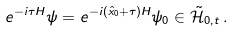<formula> <loc_0><loc_0><loc_500><loc_500>e ^ { - i \tau H } \psi = e ^ { - i \left ( \hat { x } _ { 0 } + \tau \right ) H } \psi _ { 0 } \in \tilde { \mathcal { H } } _ { 0 , t } \, .</formula> 